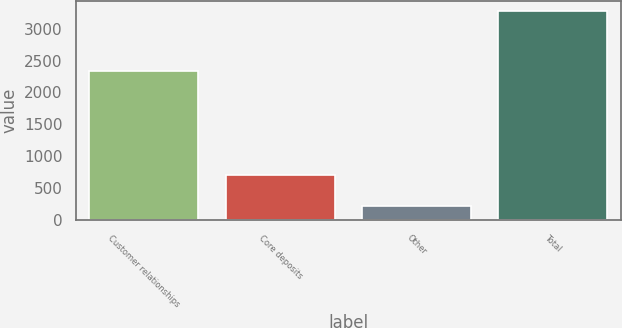<chart> <loc_0><loc_0><loc_500><loc_500><bar_chart><fcel>Customer relationships<fcel>Core deposits<fcel>Other<fcel>Total<nl><fcel>2341<fcel>710<fcel>220<fcel>3271<nl></chart> 